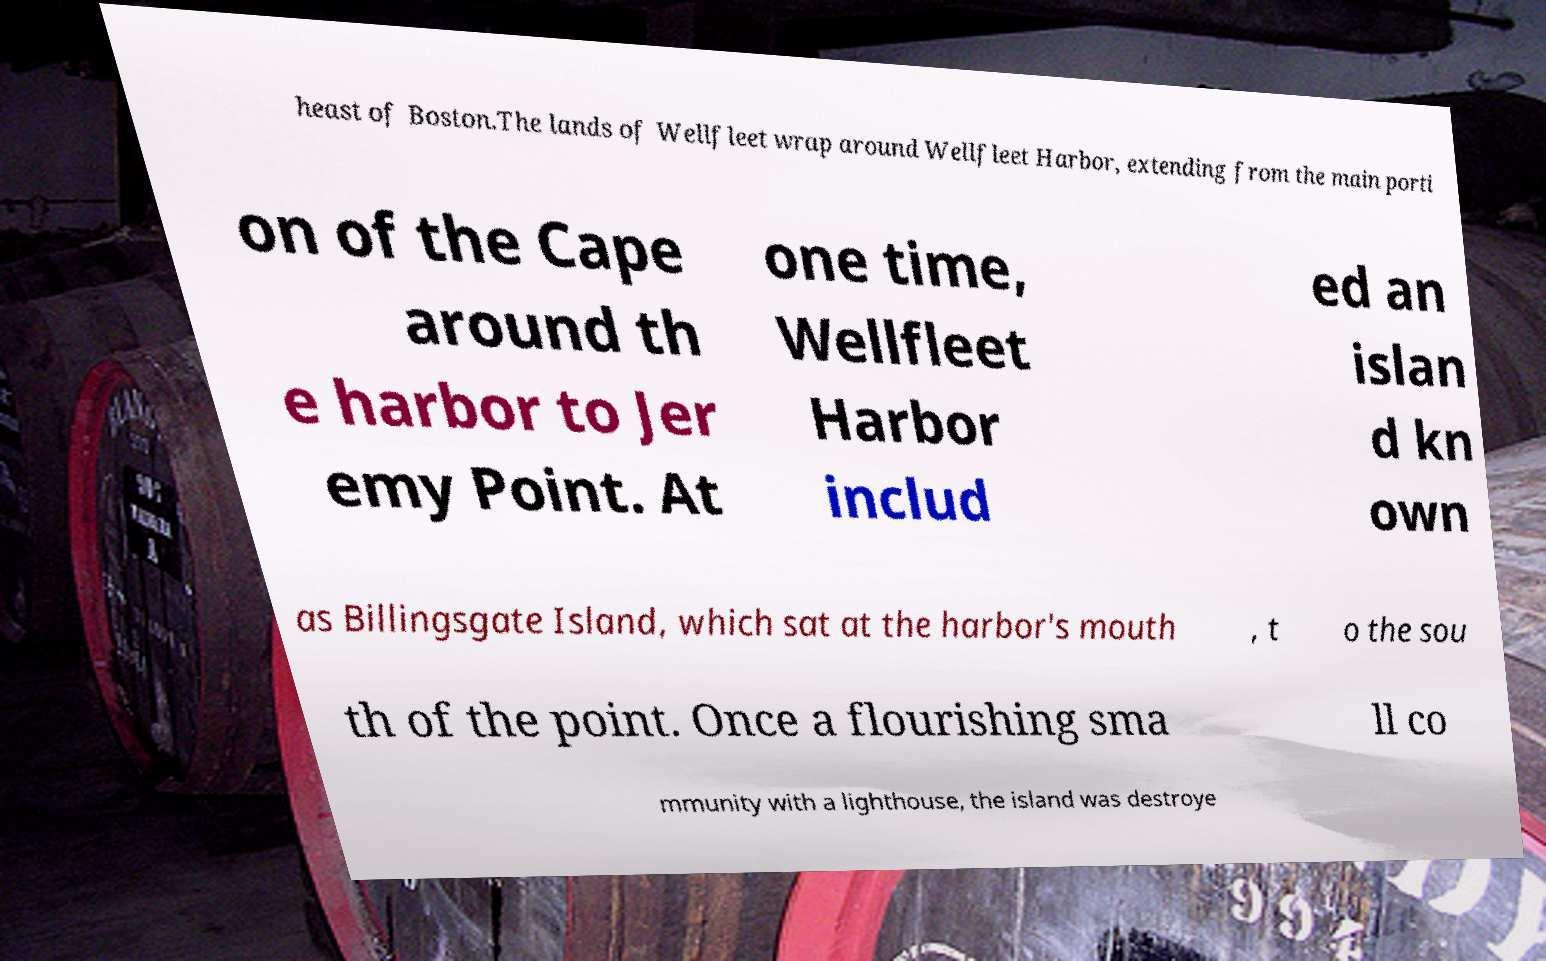There's text embedded in this image that I need extracted. Can you transcribe it verbatim? heast of Boston.The lands of Wellfleet wrap around Wellfleet Harbor, extending from the main porti on of the Cape around th e harbor to Jer emy Point. At one time, Wellfleet Harbor includ ed an islan d kn own as Billingsgate Island, which sat at the harbor's mouth , t o the sou th of the point. Once a flourishing sma ll co mmunity with a lighthouse, the island was destroye 